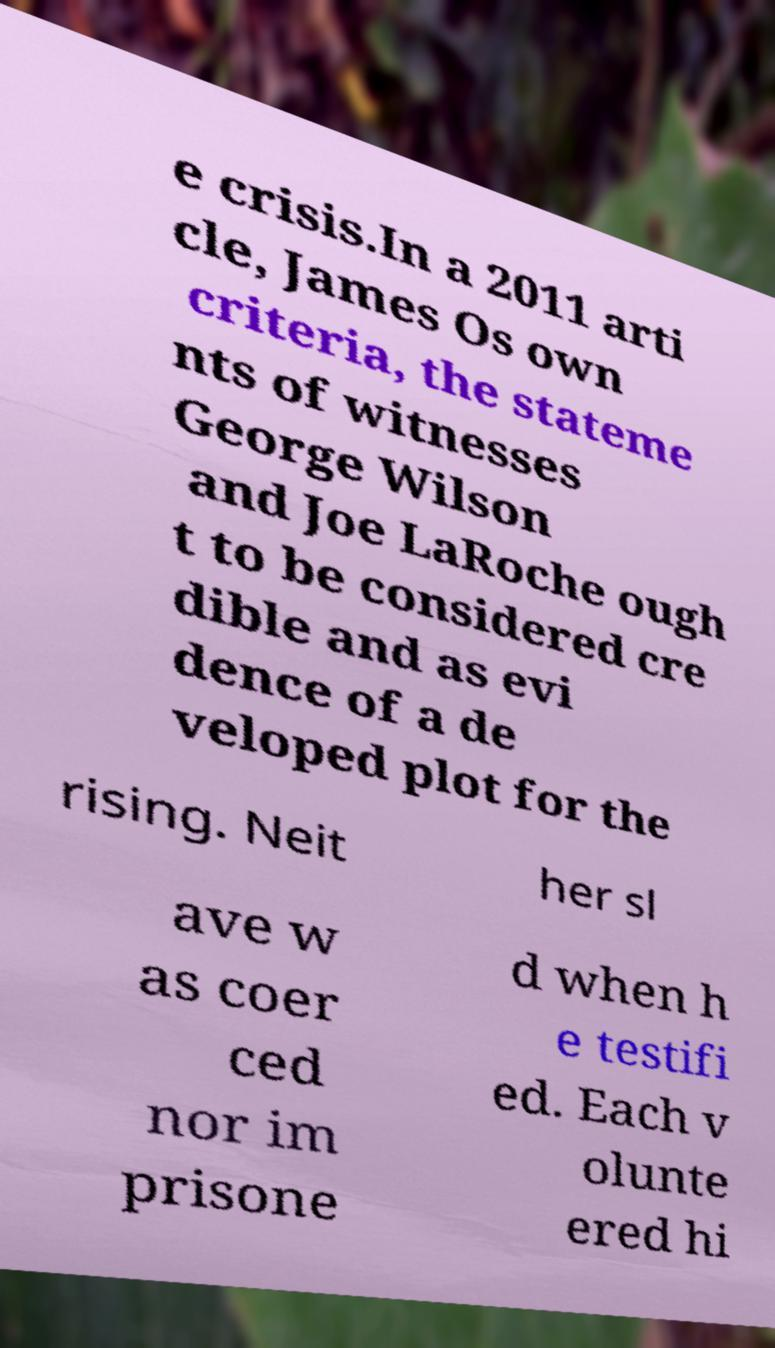For documentation purposes, I need the text within this image transcribed. Could you provide that? e crisis.In a 2011 arti cle, James Os own criteria, the stateme nts of witnesses George Wilson and Joe LaRoche ough t to be considered cre dible and as evi dence of a de veloped plot for the rising. Neit her sl ave w as coer ced nor im prisone d when h e testifi ed. Each v olunte ered hi 